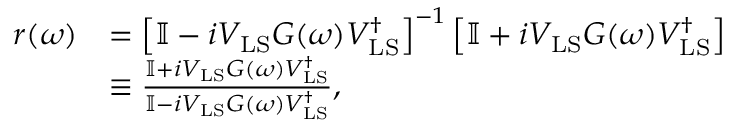<formula> <loc_0><loc_0><loc_500><loc_500>\begin{array} { r l } { r ( \omega ) } & { = \left [ \mathbb { I } - i V _ { L S } G ( \omega ) V _ { L S } ^ { \dagger } \right ] ^ { - 1 } \left [ \mathbb { I } + i V _ { L S } G ( \omega ) V _ { L S } ^ { \dagger } \right ] } \\ & { \equiv \frac { \mathbb { I } + i V _ { L S } G ( \omega ) V _ { L S } ^ { \dagger } } { \mathbb { I } - i V _ { L S } G ( \omega ) V _ { L S } ^ { \dagger } } , } \end{array}</formula> 